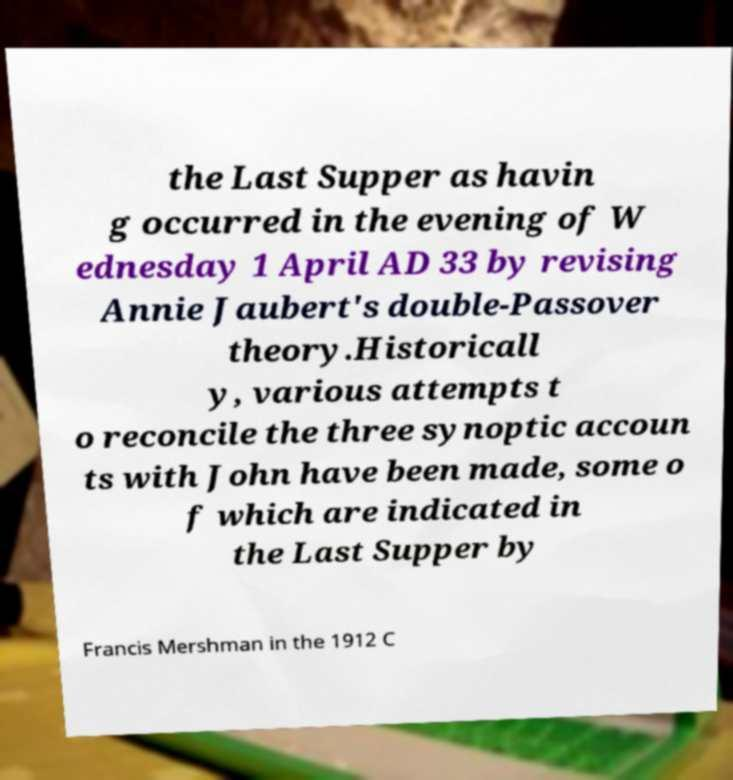Can you read and provide the text displayed in the image?This photo seems to have some interesting text. Can you extract and type it out for me? the Last Supper as havin g occurred in the evening of W ednesday 1 April AD 33 by revising Annie Jaubert's double-Passover theory.Historicall y, various attempts t o reconcile the three synoptic accoun ts with John have been made, some o f which are indicated in the Last Supper by Francis Mershman in the 1912 C 